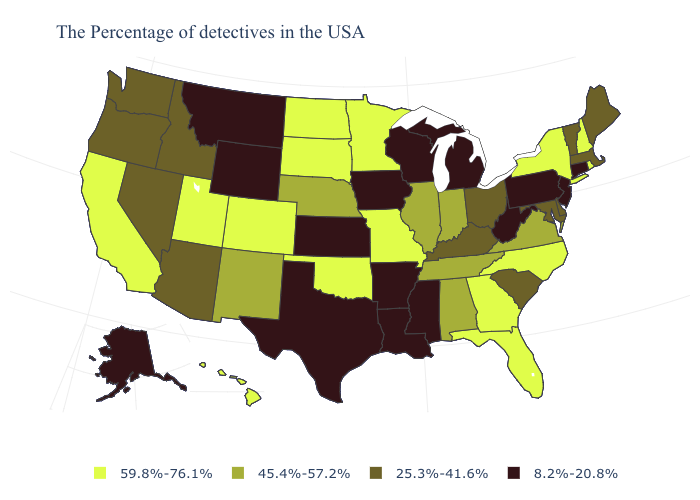Among the states that border Virginia , which have the highest value?
Be succinct. North Carolina. Does New York have the same value as Minnesota?
Concise answer only. Yes. What is the highest value in states that border New Mexico?
Short answer required. 59.8%-76.1%. Among the states that border Oklahoma , which have the highest value?
Answer briefly. Missouri, Colorado. Does Arkansas have the lowest value in the USA?
Concise answer only. Yes. Does Wisconsin have a lower value than Idaho?
Keep it brief. Yes. Is the legend a continuous bar?
Be succinct. No. Name the states that have a value in the range 25.3%-41.6%?
Concise answer only. Maine, Massachusetts, Vermont, Delaware, Maryland, South Carolina, Ohio, Kentucky, Arizona, Idaho, Nevada, Washington, Oregon. Among the states that border Virginia , does Maryland have the lowest value?
Be succinct. No. Does Nevada have the lowest value in the USA?
Quick response, please. No. What is the highest value in the MidWest ?
Concise answer only. 59.8%-76.1%. What is the value of Michigan?
Short answer required. 8.2%-20.8%. Which states hav the highest value in the MidWest?
Write a very short answer. Missouri, Minnesota, South Dakota, North Dakota. Among the states that border Massachusetts , does Vermont have the highest value?
Be succinct. No. Does Idaho have the highest value in the West?
Be succinct. No. 